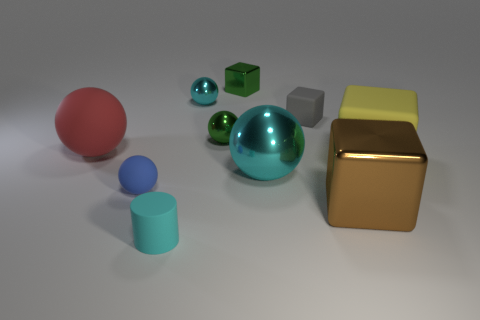Do the ball behind the small gray cube and the metallic ball right of the tiny green cube have the same color?
Your response must be concise. Yes. There is a thing that is the same color as the tiny metal cube; what size is it?
Make the answer very short. Small. There is a tiny gray object that is the same material as the tiny cyan cylinder; what is its shape?
Provide a short and direct response. Cube. Is the number of rubber spheres that are in front of the small blue ball less than the number of metal blocks in front of the big yellow thing?
Your answer should be very brief. Yes. How many big objects are gray objects or blue matte spheres?
Your answer should be compact. 0. Is the shape of the small matte thing that is behind the big yellow block the same as the large matte thing right of the large brown thing?
Provide a succinct answer. Yes. There is a cyan ball that is behind the large matte thing to the left of the rubber cube in front of the tiny gray cube; how big is it?
Your response must be concise. Small. What is the size of the block that is in front of the big yellow thing?
Keep it short and to the point. Large. What is the small block left of the large cyan object made of?
Provide a short and direct response. Metal. What number of purple objects are either large rubber balls or small shiny blocks?
Provide a short and direct response. 0. 